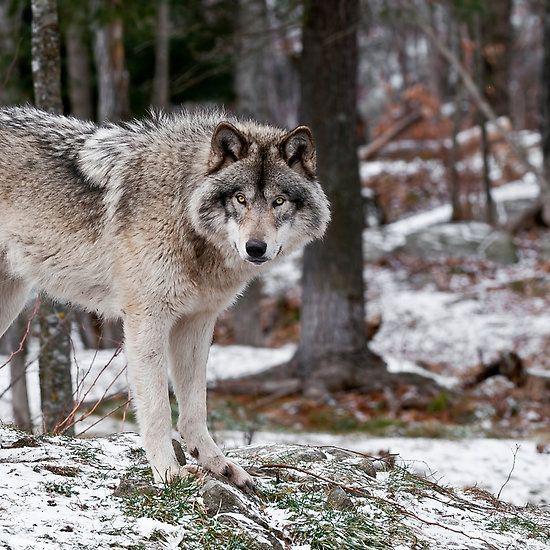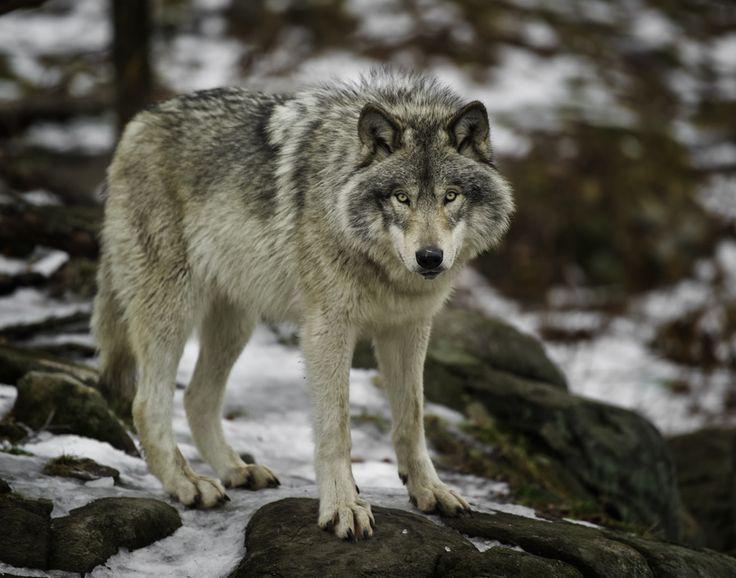The first image is the image on the left, the second image is the image on the right. Evaluate the accuracy of this statement regarding the images: "An image shows a wolf walking forward, in the general direction of the camera.". Is it true? Answer yes or no. No. The first image is the image on the left, the second image is the image on the right. Examine the images to the left and right. Is the description "The animal in the image on the right has an open mouth." accurate? Answer yes or no. No. 